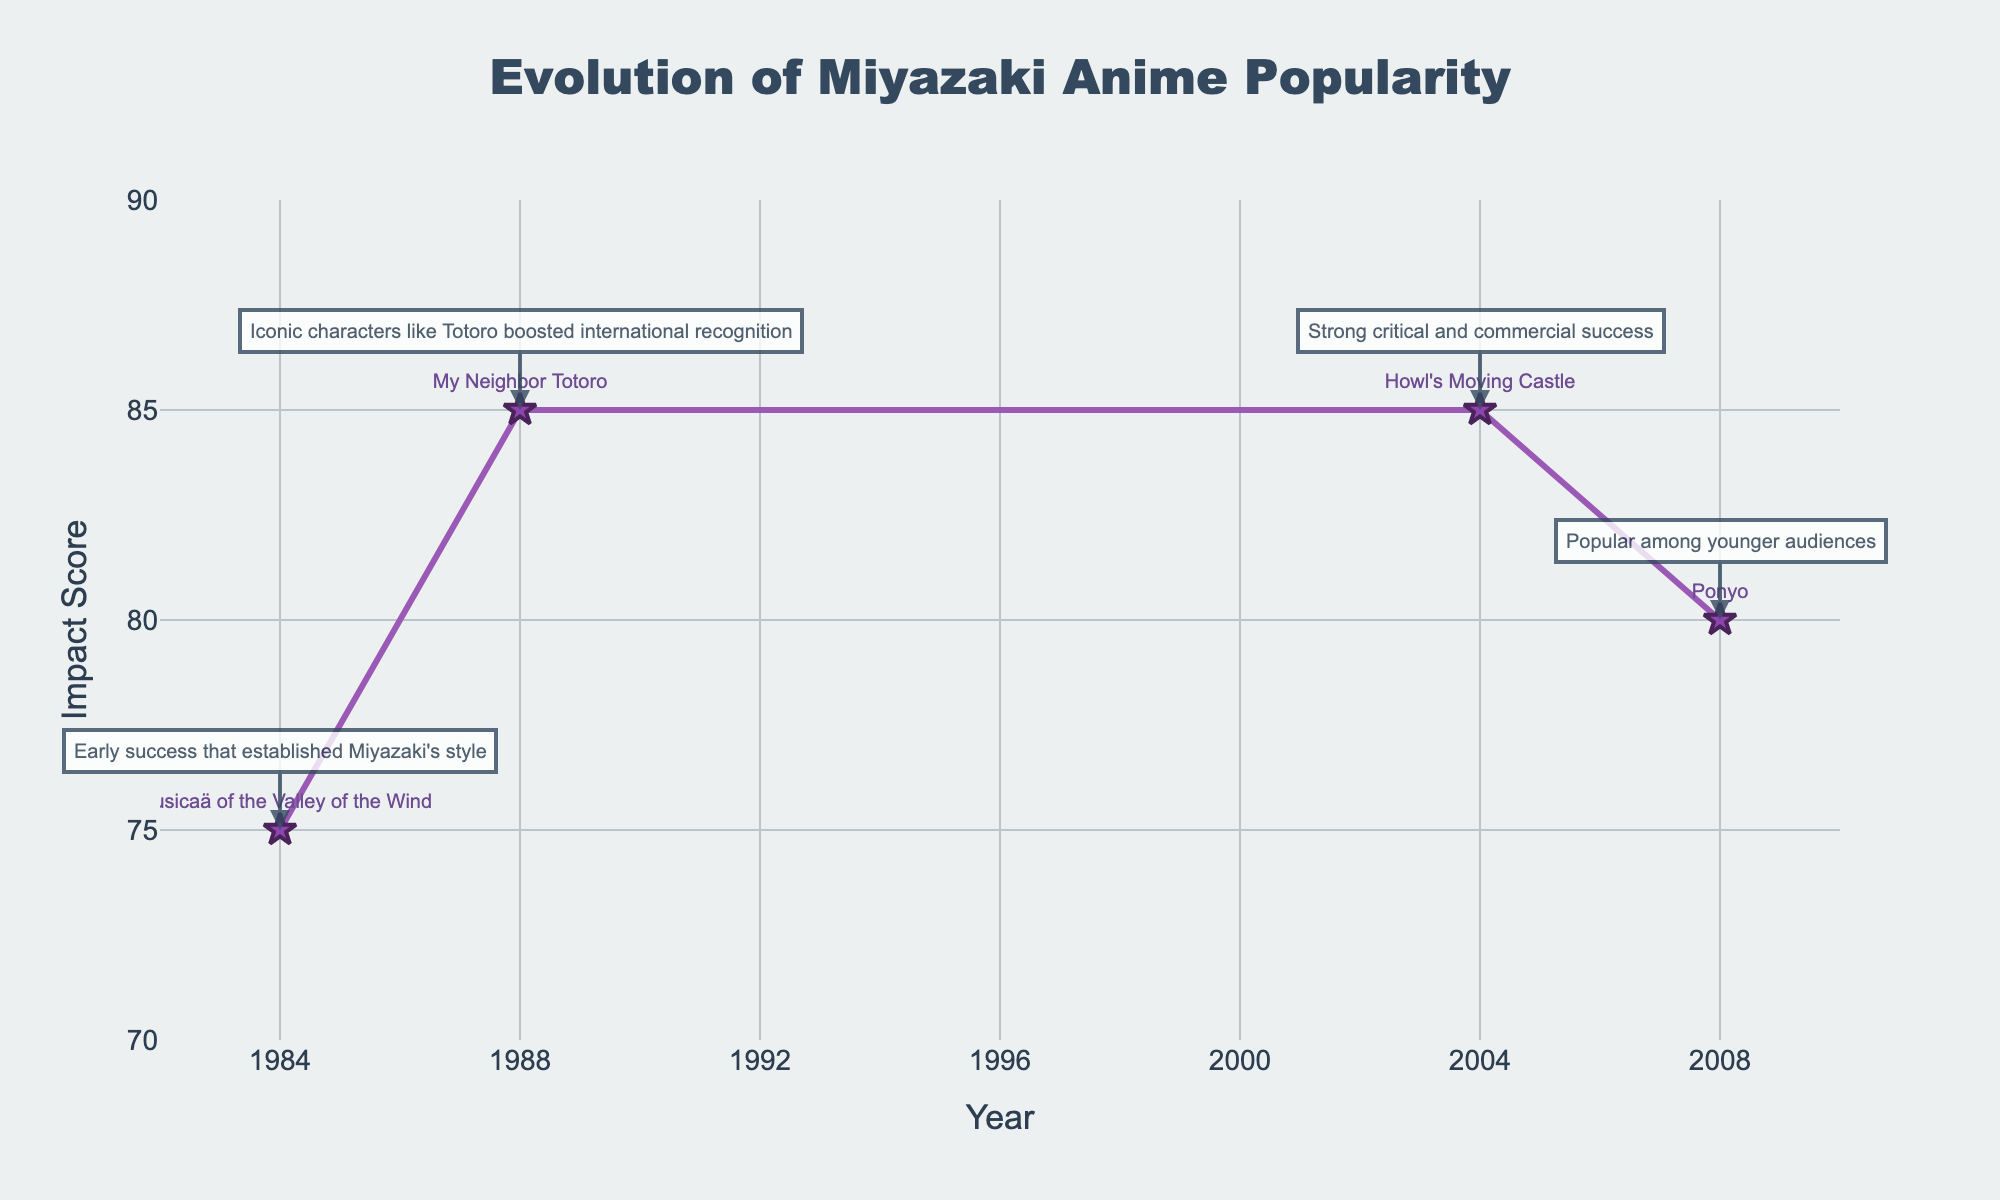What’s the title of the plot? The title of the plot is displayed prominently at the top-center of the figure.
Answer: Evolution of Miyazaki Anime Popularity What are the years highlighted in the plot? The years are marked at the x-axis and also explicitly labeled with markers at each data point corresponding to key milestone releases.
Answer: 1984, 1988, 2004, 2008 How many data points are shown in the plot? The plot shows each key milestone release against its impact score as star markers.
Answer: 4 Which Miyazaki anime has the highest impact score? By looking at the y-axis values and the corresponding data points, we observe that 'My Neighbor Totoro' and 'Howl's Moving Castle' both have the highest impact score.
Answer: My Neighbor Totoro and Howl's Moving Castle What is the range of the Impact Score on the y-axis? The y-axis range can be seen from the axis labels and the grid lines' extent on the figure.
Answer: 70 to 90 What’s the average impact score of the animes listed in the plot? Adding the impact scores (75+85+85+80) gives a sum of 325. Dividing this by the 4 data points gives the average.
Answer: 81.25 Which anime came out between 1984 and 1988? Observing the timeline on the x-axis and the labeled data points, the anime released between these years is 'My Neighbor Totoro'.
Answer: My Neighbor Totoro Which milestone release has the description "Popular among younger audiences"? By looking at the annotations near each data point, the description "Popular among younger audiences" corresponds to the release of 'Ponyo'.
Answer: Ponyo What’s the time gap between 'My Neighbor Totoro' and 'Howl's Moving Castle'? Subtracting the release year of 'My Neighbor Totoro' (1988) from 'Howl's Moving Castle' (2004) gives the time gap.
Answer: 16 years Which anime had a major commercial and critical success in 2004? Checking the data points and title labels on the x-axis for the year 2004, we find that 'Howl's Moving Castle' had significant commercial and critical success.
Answer: Howl's Moving Castle 